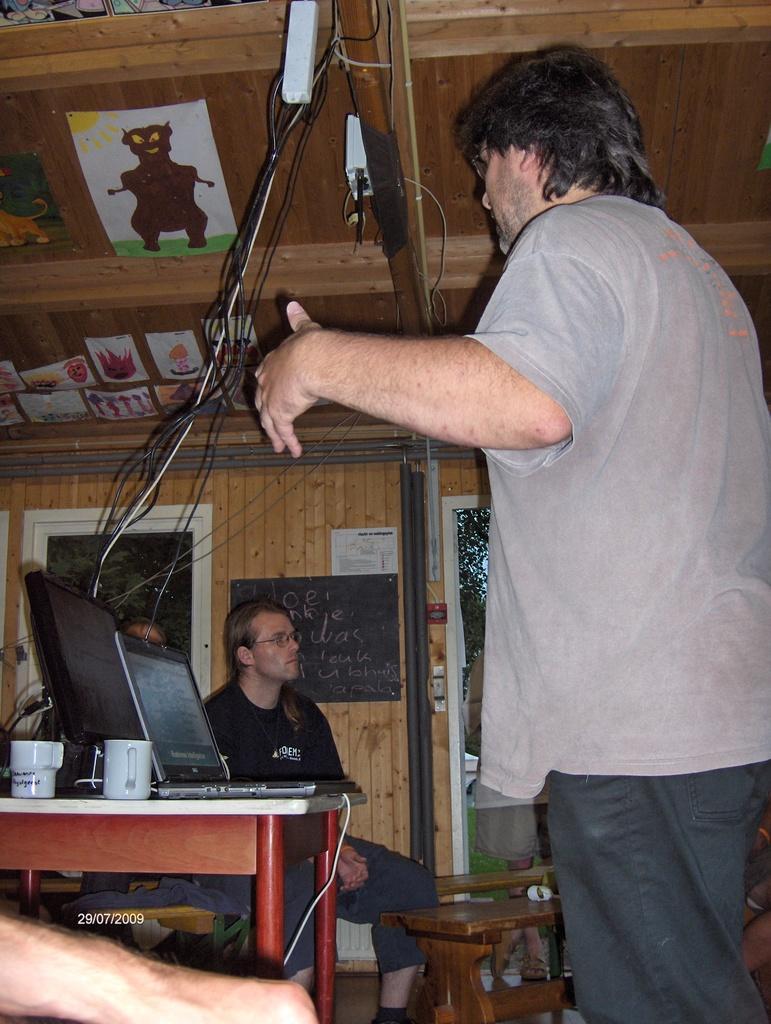In one or two sentences, can you explain what this image depicts? In this picture we can see some people, table with cups, laptop, monitor on it and in the background we can see posters, cables, window, trees and some objects. 